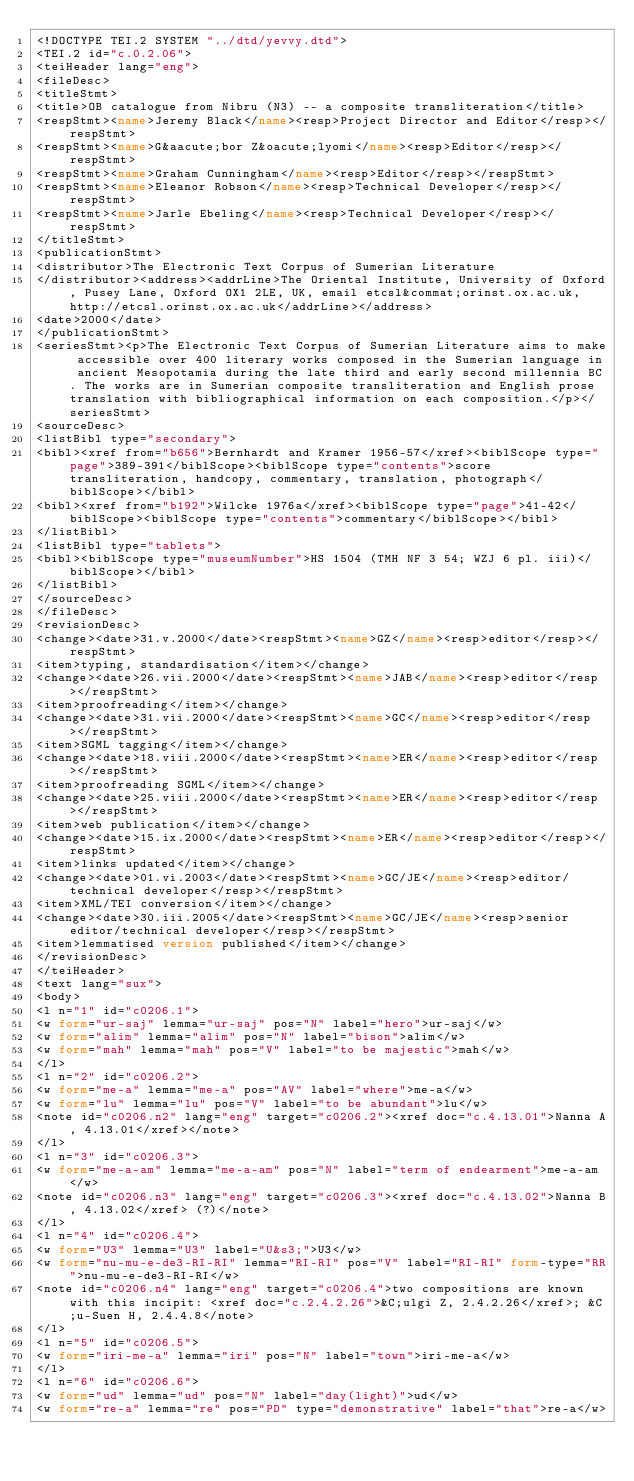<code> <loc_0><loc_0><loc_500><loc_500><_XML_><!DOCTYPE TEI.2 SYSTEM "../dtd/yevvy.dtd">
<TEI.2 id="c.0.2.06">
<teiHeader lang="eng">
<fileDesc>
<titleStmt>
<title>OB catalogue from Nibru (N3) -- a composite transliteration</title>
<respStmt><name>Jeremy Black</name><resp>Project Director and Editor</resp></respStmt>
<respStmt><name>G&aacute;bor Z&oacute;lyomi</name><resp>Editor</resp></respStmt>
<respStmt><name>Graham Cunningham</name><resp>Editor</resp></respStmt>
<respStmt><name>Eleanor Robson</name><resp>Technical Developer</resp></respStmt>
<respStmt><name>Jarle Ebeling</name><resp>Technical Developer</resp></respStmt>
</titleStmt>
<publicationStmt>
<distributor>The Electronic Text Corpus of Sumerian Literature
</distributor><address><addrLine>The Oriental Institute, University of Oxford, Pusey Lane, Oxford OX1 2LE, UK, email etcsl&commat;orinst.ox.ac.uk, http://etcsl.orinst.ox.ac.uk</addrLine></address>
<date>2000</date>
</publicationStmt>
<seriesStmt><p>The Electronic Text Corpus of Sumerian Literature aims to make accessible over 400 literary works composed in the Sumerian language in ancient Mesopotamia during the late third and early second millennia BC. The works are in Sumerian composite transliteration and English prose translation with bibliographical information on each composition.</p></seriesStmt>
<sourceDesc>
<listBibl type="secondary">
<bibl><xref from="b656">Bernhardt and Kramer 1956-57</xref><biblScope type="page">389-391</biblScope><biblScope type="contents">score transliteration, handcopy, commentary, translation, photograph</biblScope></bibl>
<bibl><xref from="b192">Wilcke 1976a</xref><biblScope type="page">41-42</biblScope><biblScope type="contents">commentary</biblScope></bibl>
</listBibl>
<listBibl type="tablets">
<bibl><biblScope type="museumNumber">HS 1504 (TMH NF 3 54; WZJ 6 pl. iii)</biblScope></bibl>
</listBibl>
</sourceDesc>
</fileDesc>
<revisionDesc>
<change><date>31.v.2000</date><respStmt><name>GZ</name><resp>editor</resp></respStmt>
<item>typing, standardisation</item></change>
<change><date>26.vii.2000</date><respStmt><name>JAB</name><resp>editor</resp></respStmt>
<item>proofreading</item></change>
<change><date>31.vii.2000</date><respStmt><name>GC</name><resp>editor</resp></respStmt>
<item>SGML tagging</item></change>
<change><date>18.viii.2000</date><respStmt><name>ER</name><resp>editor</resp></respStmt>
<item>proofreading SGML</item></change>
<change><date>25.viii.2000</date><respStmt><name>ER</name><resp>editor</resp></respStmt>
<item>web publication</item></change>
<change><date>15.ix.2000</date><respStmt><name>ER</name><resp>editor</resp></respStmt>
<item>links updated</item></change>
<change><date>01.vi.2003</date><respStmt><name>GC/JE</name><resp>editor/technical developer</resp></respStmt>
<item>XML/TEI conversion</item></change>
<change><date>30.iii.2005</date><respStmt><name>GC/JE</name><resp>senior editor/technical developer</resp></respStmt>
<item>lemmatised version published</item></change>
</revisionDesc>
</teiHeader>
<text lang="sux">
<body>
<l n="1" id="c0206.1">
<w form="ur-saj" lemma="ur-saj" pos="N" label="hero">ur-saj</w>
<w form="alim" lemma="alim" pos="N" label="bison">alim</w>
<w form="mah" lemma="mah" pos="V" label="to be majestic">mah</w>
</l>
<l n="2" id="c0206.2">
<w form="me-a" lemma="me-a" pos="AV" label="where">me-a</w>
<w form="lu" lemma="lu" pos="V" label="to be abundant">lu</w>
<note id="c0206.n2" lang="eng" target="c0206.2"><xref doc="c.4.13.01">Nanna A, 4.13.01</xref></note>
</l>
<l n="3" id="c0206.3">
<w form="me-a-am" lemma="me-a-am" pos="N" label="term of endearment">me-a-am</w>
<note id="c0206.n3" lang="eng" target="c0206.3"><xref doc="c.4.13.02">Nanna B, 4.13.02</xref> (?)</note>
</l>
<l n="4" id="c0206.4">
<w form="U3" lemma="U3" label="U&s3;">U3</w>
<w form="nu-mu-e-de3-RI-RI" lemma="RI-RI" pos="V" label="RI-RI" form-type="RR">nu-mu-e-de3-RI-RI</w>
<note id="c0206.n4" lang="eng" target="c0206.4">two compositions are known with this incipit: <xref doc="c.2.4.2.26">&C;ulgi Z, 2.4.2.26</xref>; &C;u-Suen H, 2.4.4.8</note>
</l>
<l n="5" id="c0206.5">
<w form="iri-me-a" lemma="iri" pos="N" label="town">iri-me-a</w>
</l>
<l n="6" id="c0206.6">
<w form="ud" lemma="ud" pos="N" label="day(light)">ud</w>
<w form="re-a" lemma="re" pos="PD" type="demonstrative" label="that">re-a</w></code> 